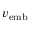<formula> <loc_0><loc_0><loc_500><loc_500>v _ { e m b }</formula> 